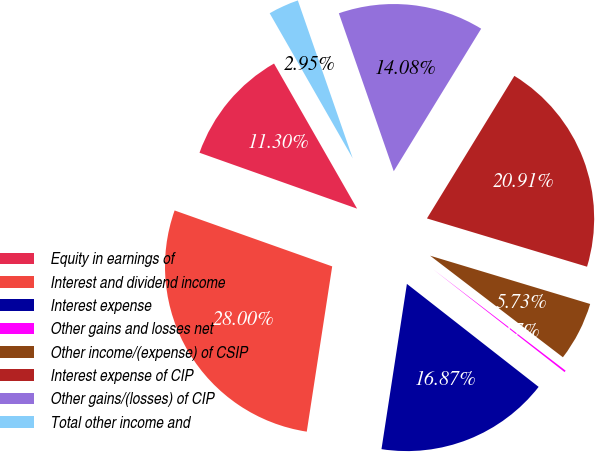Convert chart. <chart><loc_0><loc_0><loc_500><loc_500><pie_chart><fcel>Equity in earnings of<fcel>Interest and dividend income<fcel>Interest expense<fcel>Other gains and losses net<fcel>Other income/(expense) of CSIP<fcel>Interest expense of CIP<fcel>Other gains/(losses) of CIP<fcel>Total other income and<nl><fcel>11.3%<fcel>28.0%<fcel>16.87%<fcel>0.17%<fcel>5.73%<fcel>20.91%<fcel>14.08%<fcel>2.95%<nl></chart> 